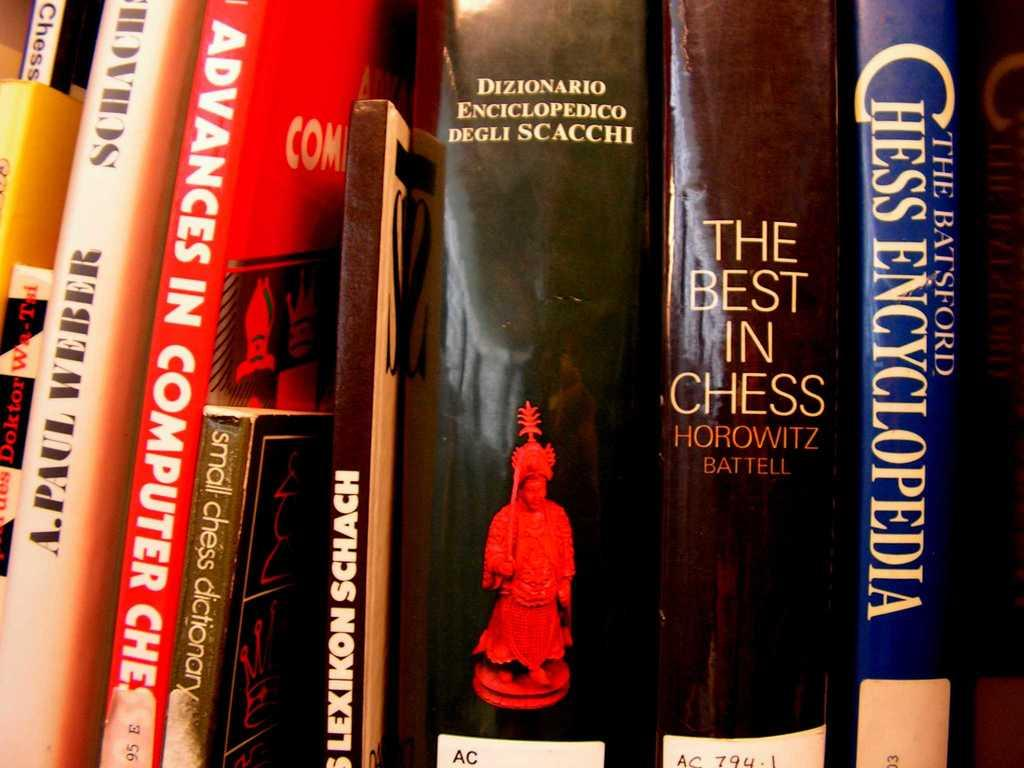<image>
Render a clear and concise summary of the photo. a row of books with one of them titled 'the batsford chess encyclopedia' 